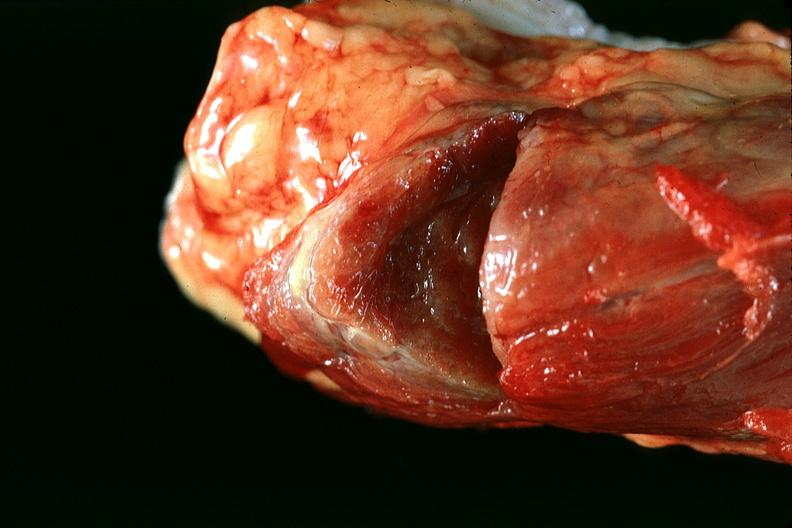what is present?
Answer the question using a single word or phrase. Endocrine 